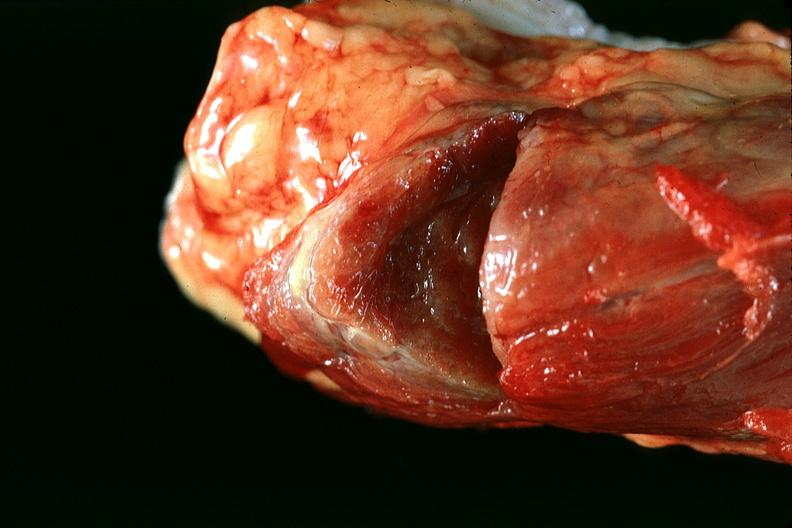what is present?
Answer the question using a single word or phrase. Endocrine 